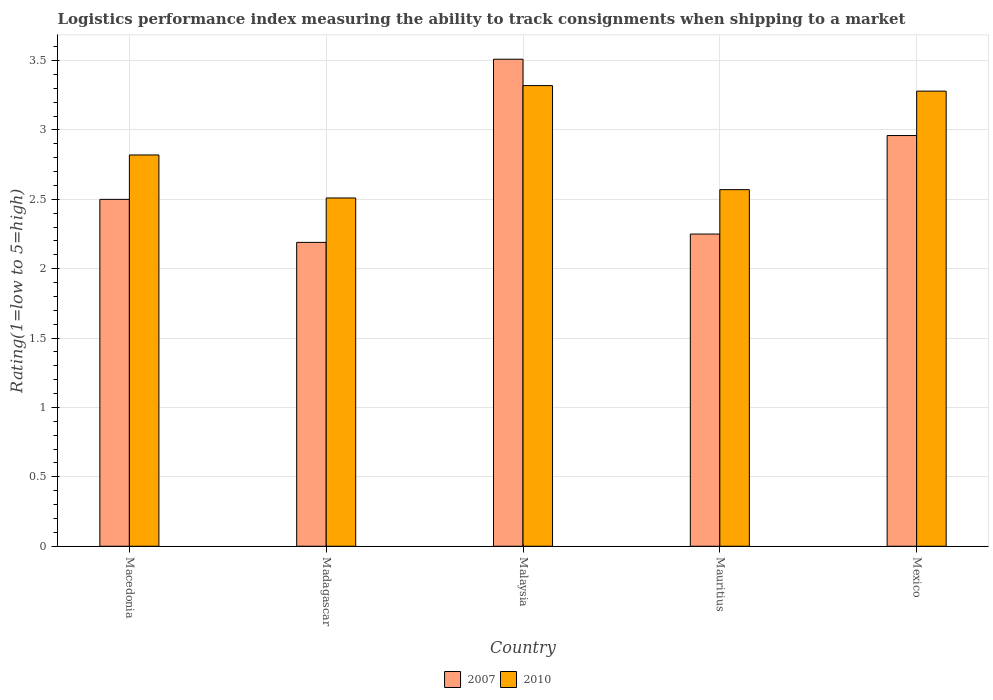How many groups of bars are there?
Offer a terse response. 5. Are the number of bars per tick equal to the number of legend labels?
Offer a terse response. Yes. What is the label of the 1st group of bars from the left?
Keep it short and to the point. Macedonia. What is the Logistic performance index in 2007 in Mexico?
Ensure brevity in your answer.  2.96. Across all countries, what is the maximum Logistic performance index in 2010?
Provide a succinct answer. 3.32. Across all countries, what is the minimum Logistic performance index in 2010?
Keep it short and to the point. 2.51. In which country was the Logistic performance index in 2007 maximum?
Offer a terse response. Malaysia. In which country was the Logistic performance index in 2007 minimum?
Your response must be concise. Madagascar. What is the total Logistic performance index in 2007 in the graph?
Keep it short and to the point. 13.41. What is the difference between the Logistic performance index in 2007 in Macedonia and that in Madagascar?
Offer a terse response. 0.31. What is the difference between the Logistic performance index in 2010 in Mexico and the Logistic performance index in 2007 in Mauritius?
Your response must be concise. 1.03. What is the average Logistic performance index in 2007 per country?
Give a very brief answer. 2.68. What is the difference between the Logistic performance index of/in 2007 and Logistic performance index of/in 2010 in Mauritius?
Offer a very short reply. -0.32. In how many countries, is the Logistic performance index in 2007 greater than 0.1?
Give a very brief answer. 5. What is the ratio of the Logistic performance index in 2010 in Malaysia to that in Mexico?
Your answer should be very brief. 1.01. Is the difference between the Logistic performance index in 2007 in Macedonia and Mauritius greater than the difference between the Logistic performance index in 2010 in Macedonia and Mauritius?
Give a very brief answer. No. What is the difference between the highest and the second highest Logistic performance index in 2010?
Your response must be concise. 0.46. What is the difference between the highest and the lowest Logistic performance index in 2007?
Ensure brevity in your answer.  1.32. What is the difference between two consecutive major ticks on the Y-axis?
Ensure brevity in your answer.  0.5. Are the values on the major ticks of Y-axis written in scientific E-notation?
Your response must be concise. No. What is the title of the graph?
Make the answer very short. Logistics performance index measuring the ability to track consignments when shipping to a market. What is the label or title of the Y-axis?
Your response must be concise. Rating(1=low to 5=high). What is the Rating(1=low to 5=high) in 2010 in Macedonia?
Offer a very short reply. 2.82. What is the Rating(1=low to 5=high) of 2007 in Madagascar?
Make the answer very short. 2.19. What is the Rating(1=low to 5=high) of 2010 in Madagascar?
Keep it short and to the point. 2.51. What is the Rating(1=low to 5=high) of 2007 in Malaysia?
Offer a terse response. 3.51. What is the Rating(1=low to 5=high) in 2010 in Malaysia?
Your answer should be very brief. 3.32. What is the Rating(1=low to 5=high) in 2007 in Mauritius?
Your response must be concise. 2.25. What is the Rating(1=low to 5=high) of 2010 in Mauritius?
Offer a terse response. 2.57. What is the Rating(1=low to 5=high) of 2007 in Mexico?
Ensure brevity in your answer.  2.96. What is the Rating(1=low to 5=high) in 2010 in Mexico?
Your answer should be very brief. 3.28. Across all countries, what is the maximum Rating(1=low to 5=high) of 2007?
Make the answer very short. 3.51. Across all countries, what is the maximum Rating(1=low to 5=high) in 2010?
Offer a terse response. 3.32. Across all countries, what is the minimum Rating(1=low to 5=high) in 2007?
Offer a very short reply. 2.19. Across all countries, what is the minimum Rating(1=low to 5=high) of 2010?
Provide a succinct answer. 2.51. What is the total Rating(1=low to 5=high) of 2007 in the graph?
Give a very brief answer. 13.41. What is the total Rating(1=low to 5=high) of 2010 in the graph?
Make the answer very short. 14.5. What is the difference between the Rating(1=low to 5=high) of 2007 in Macedonia and that in Madagascar?
Your answer should be compact. 0.31. What is the difference between the Rating(1=low to 5=high) of 2010 in Macedonia and that in Madagascar?
Give a very brief answer. 0.31. What is the difference between the Rating(1=low to 5=high) in 2007 in Macedonia and that in Malaysia?
Give a very brief answer. -1.01. What is the difference between the Rating(1=low to 5=high) in 2007 in Macedonia and that in Mauritius?
Ensure brevity in your answer.  0.25. What is the difference between the Rating(1=low to 5=high) of 2010 in Macedonia and that in Mauritius?
Your response must be concise. 0.25. What is the difference between the Rating(1=low to 5=high) of 2007 in Macedonia and that in Mexico?
Give a very brief answer. -0.46. What is the difference between the Rating(1=low to 5=high) in 2010 in Macedonia and that in Mexico?
Provide a short and direct response. -0.46. What is the difference between the Rating(1=low to 5=high) of 2007 in Madagascar and that in Malaysia?
Your answer should be compact. -1.32. What is the difference between the Rating(1=low to 5=high) of 2010 in Madagascar and that in Malaysia?
Ensure brevity in your answer.  -0.81. What is the difference between the Rating(1=low to 5=high) in 2007 in Madagascar and that in Mauritius?
Your response must be concise. -0.06. What is the difference between the Rating(1=low to 5=high) in 2010 in Madagascar and that in Mauritius?
Give a very brief answer. -0.06. What is the difference between the Rating(1=low to 5=high) in 2007 in Madagascar and that in Mexico?
Your answer should be very brief. -0.77. What is the difference between the Rating(1=low to 5=high) of 2010 in Madagascar and that in Mexico?
Ensure brevity in your answer.  -0.77. What is the difference between the Rating(1=low to 5=high) in 2007 in Malaysia and that in Mauritius?
Keep it short and to the point. 1.26. What is the difference between the Rating(1=low to 5=high) in 2010 in Malaysia and that in Mauritius?
Your response must be concise. 0.75. What is the difference between the Rating(1=low to 5=high) in 2007 in Malaysia and that in Mexico?
Ensure brevity in your answer.  0.55. What is the difference between the Rating(1=low to 5=high) in 2007 in Mauritius and that in Mexico?
Your answer should be very brief. -0.71. What is the difference between the Rating(1=low to 5=high) in 2010 in Mauritius and that in Mexico?
Offer a very short reply. -0.71. What is the difference between the Rating(1=low to 5=high) of 2007 in Macedonia and the Rating(1=low to 5=high) of 2010 in Madagascar?
Keep it short and to the point. -0.01. What is the difference between the Rating(1=low to 5=high) of 2007 in Macedonia and the Rating(1=low to 5=high) of 2010 in Malaysia?
Your answer should be very brief. -0.82. What is the difference between the Rating(1=low to 5=high) of 2007 in Macedonia and the Rating(1=low to 5=high) of 2010 in Mauritius?
Ensure brevity in your answer.  -0.07. What is the difference between the Rating(1=low to 5=high) in 2007 in Macedonia and the Rating(1=low to 5=high) in 2010 in Mexico?
Keep it short and to the point. -0.78. What is the difference between the Rating(1=low to 5=high) of 2007 in Madagascar and the Rating(1=low to 5=high) of 2010 in Malaysia?
Keep it short and to the point. -1.13. What is the difference between the Rating(1=low to 5=high) of 2007 in Madagascar and the Rating(1=low to 5=high) of 2010 in Mauritius?
Provide a short and direct response. -0.38. What is the difference between the Rating(1=low to 5=high) of 2007 in Madagascar and the Rating(1=low to 5=high) of 2010 in Mexico?
Provide a succinct answer. -1.09. What is the difference between the Rating(1=low to 5=high) of 2007 in Malaysia and the Rating(1=low to 5=high) of 2010 in Mexico?
Offer a terse response. 0.23. What is the difference between the Rating(1=low to 5=high) in 2007 in Mauritius and the Rating(1=low to 5=high) in 2010 in Mexico?
Offer a very short reply. -1.03. What is the average Rating(1=low to 5=high) in 2007 per country?
Provide a succinct answer. 2.68. What is the average Rating(1=low to 5=high) of 2010 per country?
Make the answer very short. 2.9. What is the difference between the Rating(1=low to 5=high) of 2007 and Rating(1=low to 5=high) of 2010 in Macedonia?
Offer a terse response. -0.32. What is the difference between the Rating(1=low to 5=high) in 2007 and Rating(1=low to 5=high) in 2010 in Madagascar?
Provide a succinct answer. -0.32. What is the difference between the Rating(1=low to 5=high) in 2007 and Rating(1=low to 5=high) in 2010 in Malaysia?
Your answer should be compact. 0.19. What is the difference between the Rating(1=low to 5=high) in 2007 and Rating(1=low to 5=high) in 2010 in Mauritius?
Your answer should be compact. -0.32. What is the difference between the Rating(1=low to 5=high) of 2007 and Rating(1=low to 5=high) of 2010 in Mexico?
Provide a short and direct response. -0.32. What is the ratio of the Rating(1=low to 5=high) in 2007 in Macedonia to that in Madagascar?
Your answer should be very brief. 1.14. What is the ratio of the Rating(1=low to 5=high) in 2010 in Macedonia to that in Madagascar?
Your response must be concise. 1.12. What is the ratio of the Rating(1=low to 5=high) of 2007 in Macedonia to that in Malaysia?
Ensure brevity in your answer.  0.71. What is the ratio of the Rating(1=low to 5=high) of 2010 in Macedonia to that in Malaysia?
Make the answer very short. 0.85. What is the ratio of the Rating(1=low to 5=high) in 2010 in Macedonia to that in Mauritius?
Your answer should be compact. 1.1. What is the ratio of the Rating(1=low to 5=high) of 2007 in Macedonia to that in Mexico?
Provide a succinct answer. 0.84. What is the ratio of the Rating(1=low to 5=high) of 2010 in Macedonia to that in Mexico?
Offer a very short reply. 0.86. What is the ratio of the Rating(1=low to 5=high) of 2007 in Madagascar to that in Malaysia?
Your answer should be compact. 0.62. What is the ratio of the Rating(1=low to 5=high) of 2010 in Madagascar to that in Malaysia?
Your answer should be very brief. 0.76. What is the ratio of the Rating(1=low to 5=high) of 2007 in Madagascar to that in Mauritius?
Your response must be concise. 0.97. What is the ratio of the Rating(1=low to 5=high) of 2010 in Madagascar to that in Mauritius?
Offer a terse response. 0.98. What is the ratio of the Rating(1=low to 5=high) in 2007 in Madagascar to that in Mexico?
Keep it short and to the point. 0.74. What is the ratio of the Rating(1=low to 5=high) in 2010 in Madagascar to that in Mexico?
Offer a terse response. 0.77. What is the ratio of the Rating(1=low to 5=high) of 2007 in Malaysia to that in Mauritius?
Your response must be concise. 1.56. What is the ratio of the Rating(1=low to 5=high) in 2010 in Malaysia to that in Mauritius?
Provide a succinct answer. 1.29. What is the ratio of the Rating(1=low to 5=high) of 2007 in Malaysia to that in Mexico?
Give a very brief answer. 1.19. What is the ratio of the Rating(1=low to 5=high) of 2010 in Malaysia to that in Mexico?
Give a very brief answer. 1.01. What is the ratio of the Rating(1=low to 5=high) of 2007 in Mauritius to that in Mexico?
Keep it short and to the point. 0.76. What is the ratio of the Rating(1=low to 5=high) of 2010 in Mauritius to that in Mexico?
Offer a very short reply. 0.78. What is the difference between the highest and the second highest Rating(1=low to 5=high) in 2007?
Your answer should be compact. 0.55. What is the difference between the highest and the second highest Rating(1=low to 5=high) in 2010?
Keep it short and to the point. 0.04. What is the difference between the highest and the lowest Rating(1=low to 5=high) in 2007?
Your response must be concise. 1.32. What is the difference between the highest and the lowest Rating(1=low to 5=high) of 2010?
Provide a short and direct response. 0.81. 